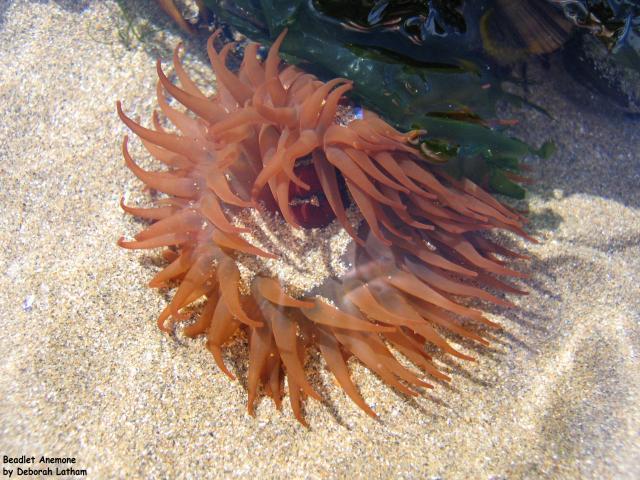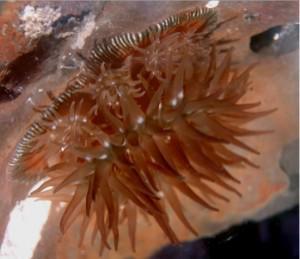The first image is the image on the left, the second image is the image on the right. Examine the images to the left and right. Is the description "One of the images has more than three anemones visible." accurate? Answer yes or no. No. The first image is the image on the left, the second image is the image on the right. For the images displayed, is the sentence "All images feature anemone with tapering non-spike 'soft' tendrils, but one image features an anemone that has a deeper and more solid color than the other image." factually correct? Answer yes or no. No. 